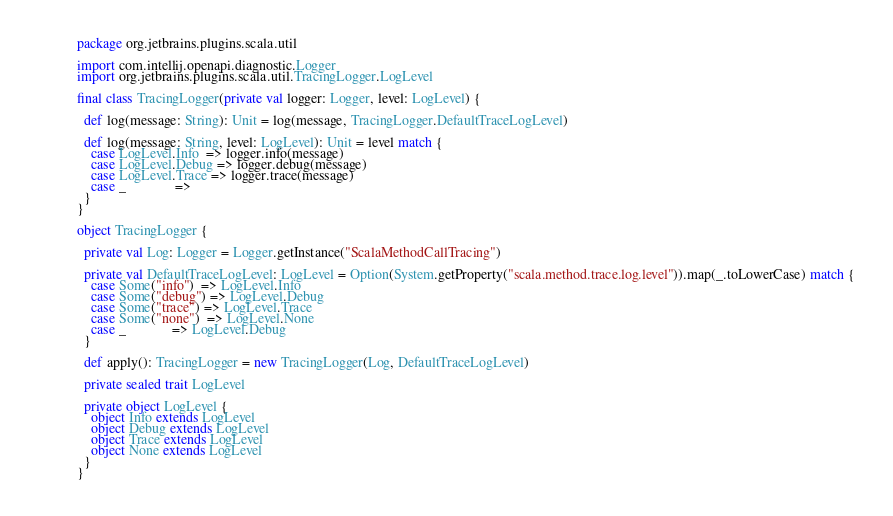Convert code to text. <code><loc_0><loc_0><loc_500><loc_500><_Scala_>package org.jetbrains.plugins.scala.util

import com.intellij.openapi.diagnostic.Logger
import org.jetbrains.plugins.scala.util.TracingLogger.LogLevel

final class TracingLogger(private val logger: Logger, level: LogLevel) {

  def log(message: String): Unit = log(message, TracingLogger.DefaultTraceLogLevel)

  def log(message: String, level: LogLevel): Unit = level match {
    case LogLevel.Info  => logger.info(message)
    case LogLevel.Debug => logger.debug(message)
    case LogLevel.Trace => logger.trace(message)
    case _              =>
  }
}

object TracingLogger {

  private val Log: Logger = Logger.getInstance("ScalaMethodCallTracing")

  private val DefaultTraceLogLevel: LogLevel = Option(System.getProperty("scala.method.trace.log.level")).map(_.toLowerCase) match {
    case Some("info")  => LogLevel.Info
    case Some("debug") => LogLevel.Debug
    case Some("trace") => LogLevel.Trace
    case Some("none")  => LogLevel.None
    case _             => LogLevel.Debug
  }

  def apply(): TracingLogger = new TracingLogger(Log, DefaultTraceLogLevel)

  private sealed trait LogLevel

  private object LogLevel {
    object Info extends LogLevel
    object Debug extends LogLevel
    object Trace extends LogLevel
    object None extends LogLevel
  }
}</code> 